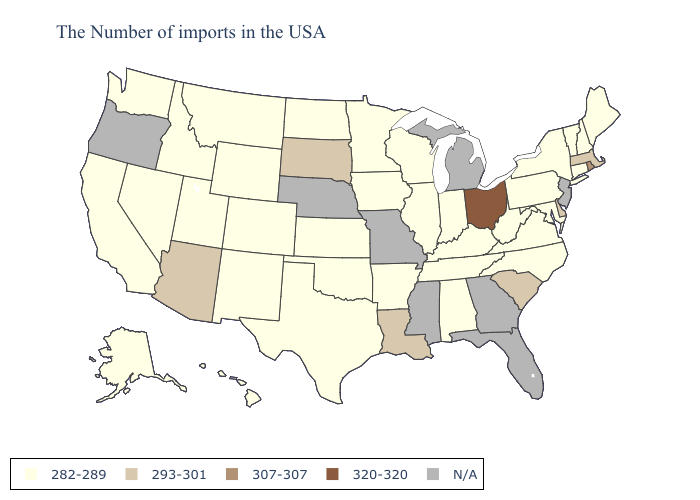Among the states that border Wyoming , does Idaho have the highest value?
Quick response, please. No. Name the states that have a value in the range 320-320?
Short answer required. Ohio. What is the value of Louisiana?
Write a very short answer. 293-301. Name the states that have a value in the range 307-307?
Answer briefly. Rhode Island. Does Alabama have the lowest value in the South?
Concise answer only. Yes. What is the value of Nevada?
Concise answer only. 282-289. Which states have the lowest value in the USA?
Be succinct. Maine, New Hampshire, Vermont, Connecticut, New York, Maryland, Pennsylvania, Virginia, North Carolina, West Virginia, Kentucky, Indiana, Alabama, Tennessee, Wisconsin, Illinois, Arkansas, Minnesota, Iowa, Kansas, Oklahoma, Texas, North Dakota, Wyoming, Colorado, New Mexico, Utah, Montana, Idaho, Nevada, California, Washington, Alaska, Hawaii. Is the legend a continuous bar?
Keep it brief. No. Name the states that have a value in the range 293-301?
Answer briefly. Massachusetts, Delaware, South Carolina, Louisiana, South Dakota, Arizona. What is the value of Hawaii?
Answer briefly. 282-289. What is the value of Illinois?
Keep it brief. 282-289. Does North Carolina have the highest value in the South?
Quick response, please. No. Does the map have missing data?
Be succinct. Yes. 